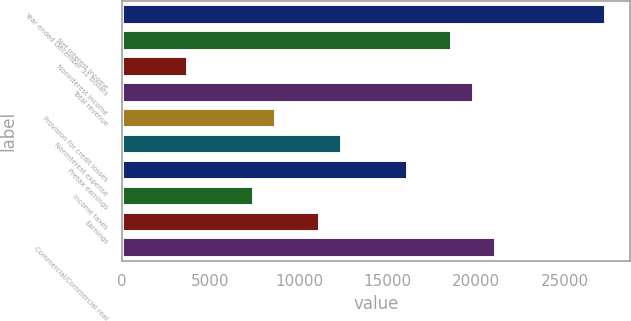<chart> <loc_0><loc_0><loc_500><loc_500><bar_chart><fcel>Year ended December 31 Dollars<fcel>Net interest income<fcel>Noninterest income<fcel>Total revenue<fcel>Provision for credit losses<fcel>Noninterest expense<fcel>Pretax earnings<fcel>Income taxes<fcel>Earnings<fcel>Commercial/Commercial real<nl><fcel>27308.4<fcel>18620<fcel>3725.57<fcel>19861.2<fcel>8690.37<fcel>12414<fcel>16137.6<fcel>7449.17<fcel>11172.8<fcel>21102.4<nl></chart> 